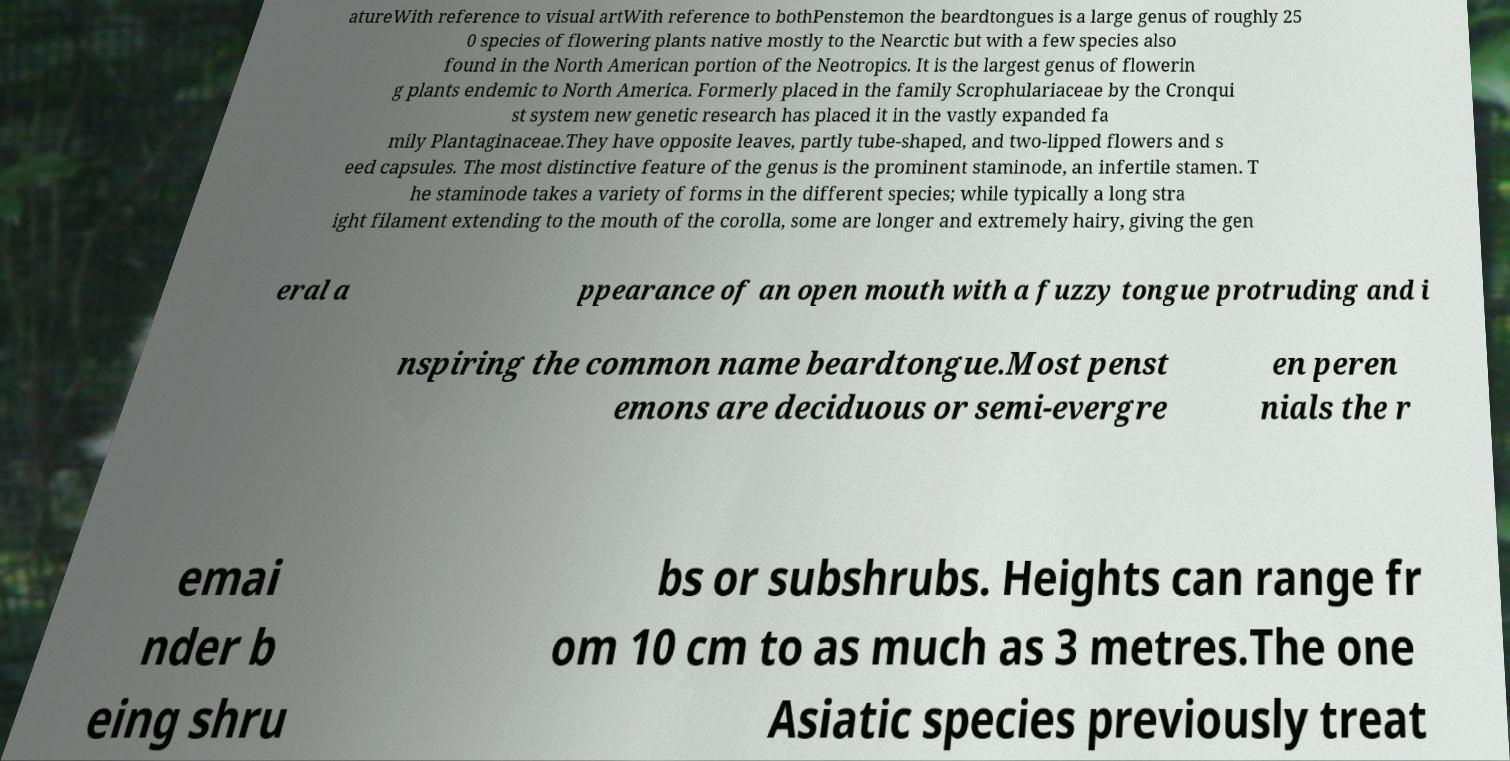Can you read and provide the text displayed in the image?This photo seems to have some interesting text. Can you extract and type it out for me? atureWith reference to visual artWith reference to bothPenstemon the beardtongues is a large genus of roughly 25 0 species of flowering plants native mostly to the Nearctic but with a few species also found in the North American portion of the Neotropics. It is the largest genus of flowerin g plants endemic to North America. Formerly placed in the family Scrophulariaceae by the Cronqui st system new genetic research has placed it in the vastly expanded fa mily Plantaginaceae.They have opposite leaves, partly tube-shaped, and two-lipped flowers and s eed capsules. The most distinctive feature of the genus is the prominent staminode, an infertile stamen. T he staminode takes a variety of forms in the different species; while typically a long stra ight filament extending to the mouth of the corolla, some are longer and extremely hairy, giving the gen eral a ppearance of an open mouth with a fuzzy tongue protruding and i nspiring the common name beardtongue.Most penst emons are deciduous or semi-evergre en peren nials the r emai nder b eing shru bs or subshrubs. Heights can range fr om 10 cm to as much as 3 metres.The one Asiatic species previously treat 